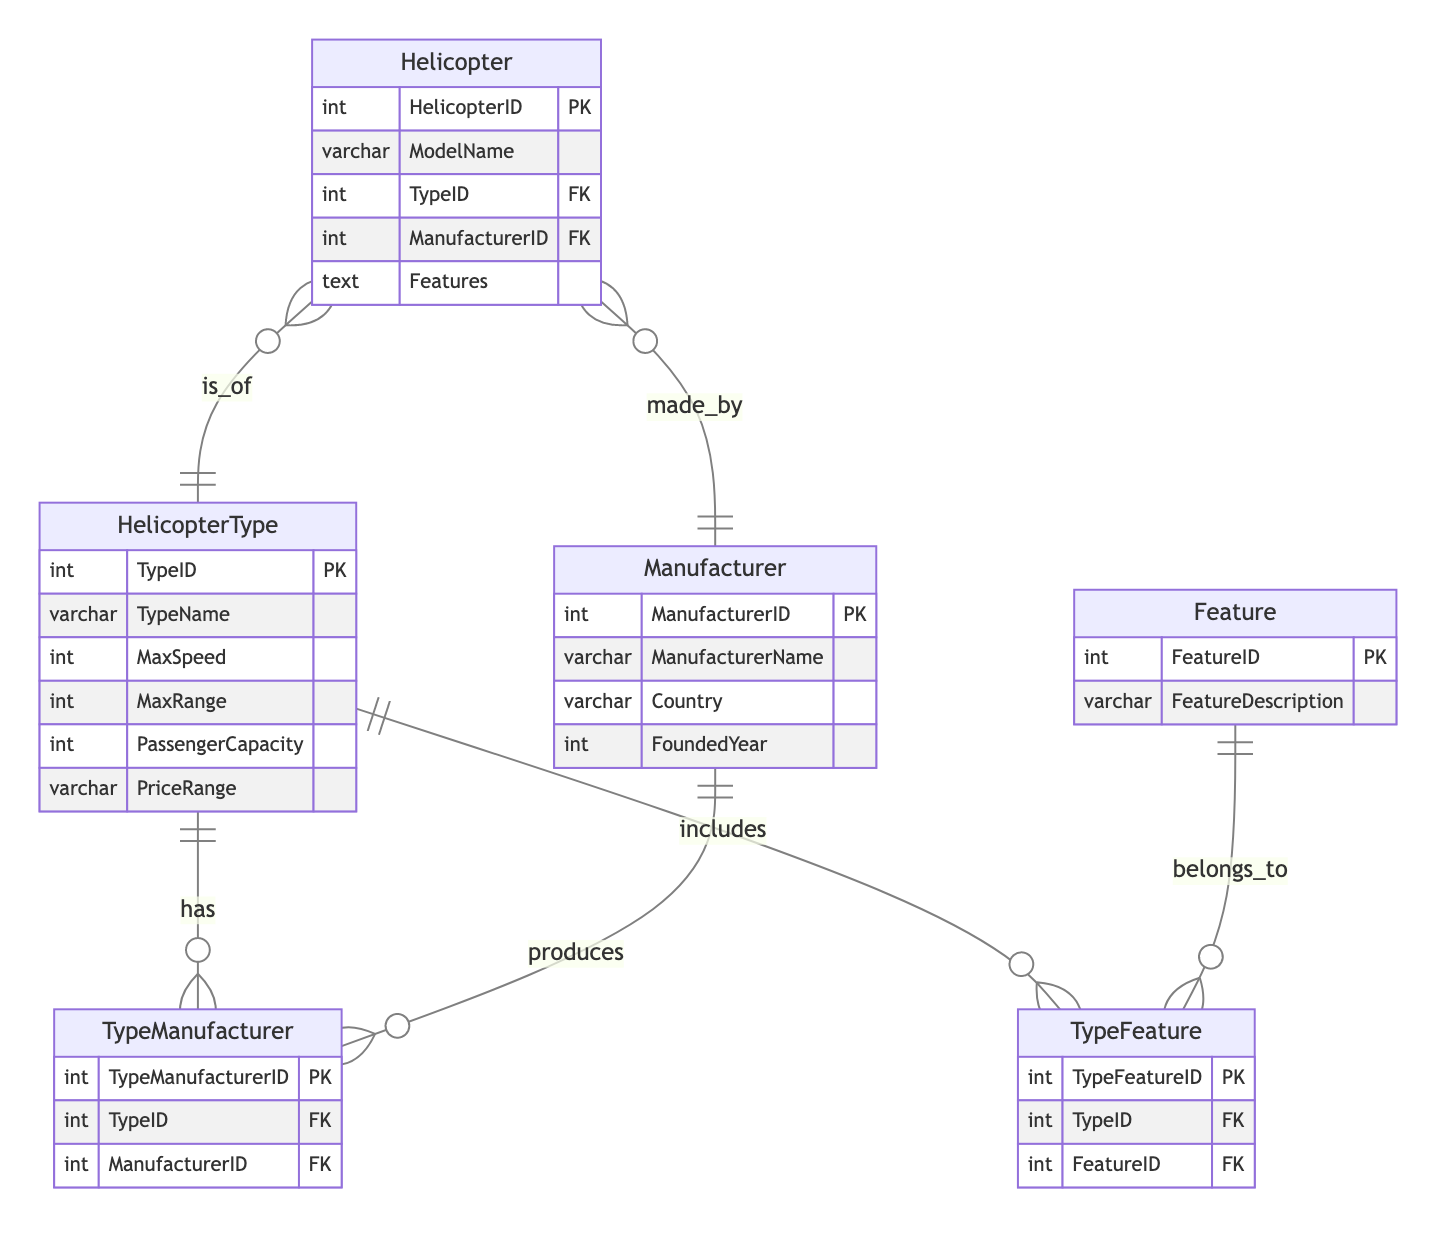What entities are in the diagram? The diagram includes four entities: HelicopterType, Manufacturer, Feature, and Helicopter. These entities represent the primary objects in the system and their attributes are defined under each.
Answer: HelicopterType, Manufacturer, Feature, Helicopter How many helicopters are associated with each type? The relationship between Helicopter and HelicopterType indicates that one type may have many helicopters associated with it, but the exact count isn't specified in the diagram. It is determined by the actual instances in the database.
Answer: Many Which entity contains the Manufacturer's country information? The Manufacturer entity contains the ManufacturerName, Country, and FoundedYear attributes, and among these, Country reflects the geographical information related to the manufacturer.
Answer: Manufacturer What does the TypeFeature relationship denote? The TypeFeature relationship represents a many-to-many connection between HelicopterType and Feature, signifying that one helicopter type can have multiple features, and a feature can belong to multiple helicopter types.
Answer: Many-to-many What information does the HelicopterType entity provide about speed? The HelicopterType entity includes the MaxSpeed attribute, which specifically details the maximum speed a helicopter of that type can achieve, represented as an integer.
Answer: MaxSpeed If a helicopter model is made by a particular manufacturer, which relationship describes this? The relationship that describes this association is the "is_of" relationship, indicating that the Helicopter entity is associated with a specific HelicopterType, while the "made_by" relationship connects Helicopters to their respective Manufacturers.
Answer: made_by How are features related to helicopter types? Features are related to helicopter types through the TypeFeature relationship, allowing multiple features to be associated with any given helicopter type and vice versa. The relationship signifies this many-to-many association.
Answer: Many-to-many How many attributes does the Manufacturer entity have? The Manufacturer entity contains four attributes: ManufacturerID, ManufacturerName, Country, and FoundedYear, which encapsulate essential information about the manufacturer.
Answer: Four What kind of information can be expected in the PriceRange attribute? The PriceRange attribute typically includes a categorical description of the price range for a specific helicopter type, providing prospective buyers an idea about cost but not exact figures.
Answer: Categorical description 